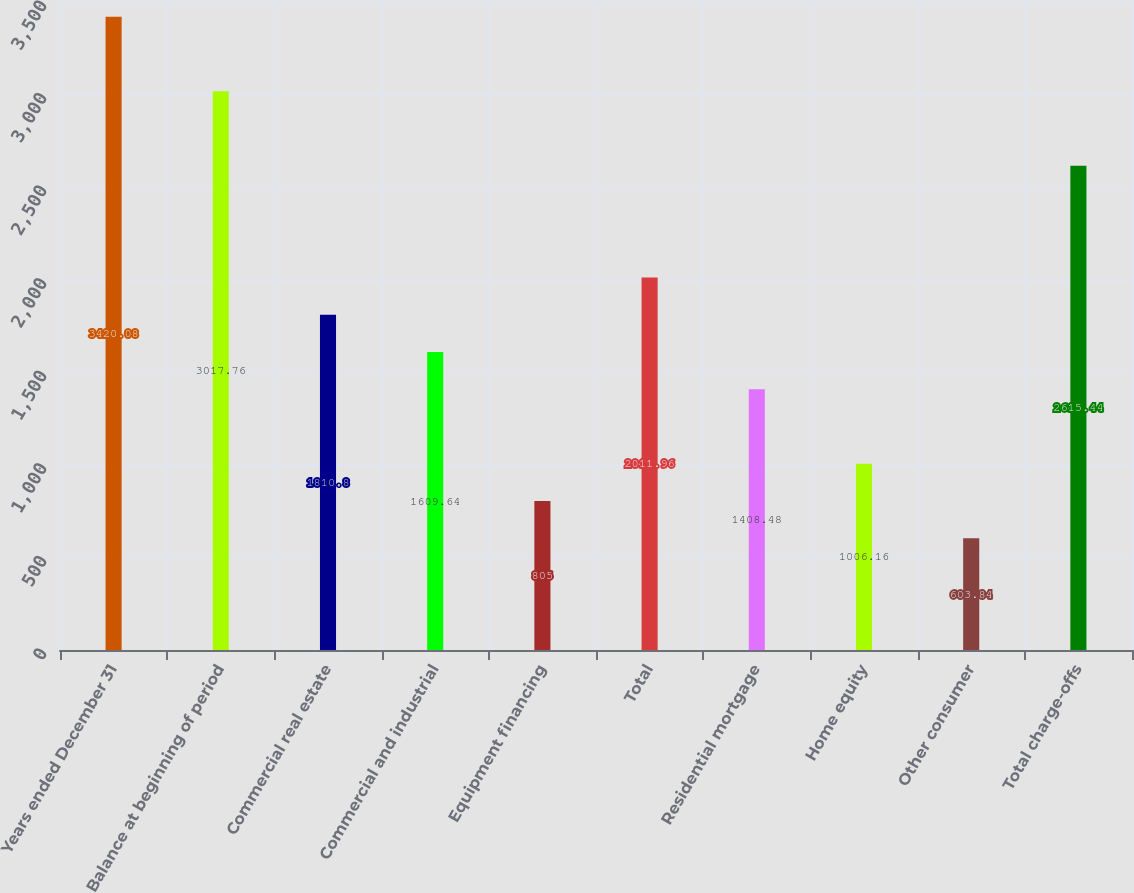Convert chart. <chart><loc_0><loc_0><loc_500><loc_500><bar_chart><fcel>Years ended December 31<fcel>Balance at beginning of period<fcel>Commercial real estate<fcel>Commercial and industrial<fcel>Equipment financing<fcel>Total<fcel>Residential mortgage<fcel>Home equity<fcel>Other consumer<fcel>Total charge-offs<nl><fcel>3420.08<fcel>3017.76<fcel>1810.8<fcel>1609.64<fcel>805<fcel>2011.96<fcel>1408.48<fcel>1006.16<fcel>603.84<fcel>2615.44<nl></chart> 